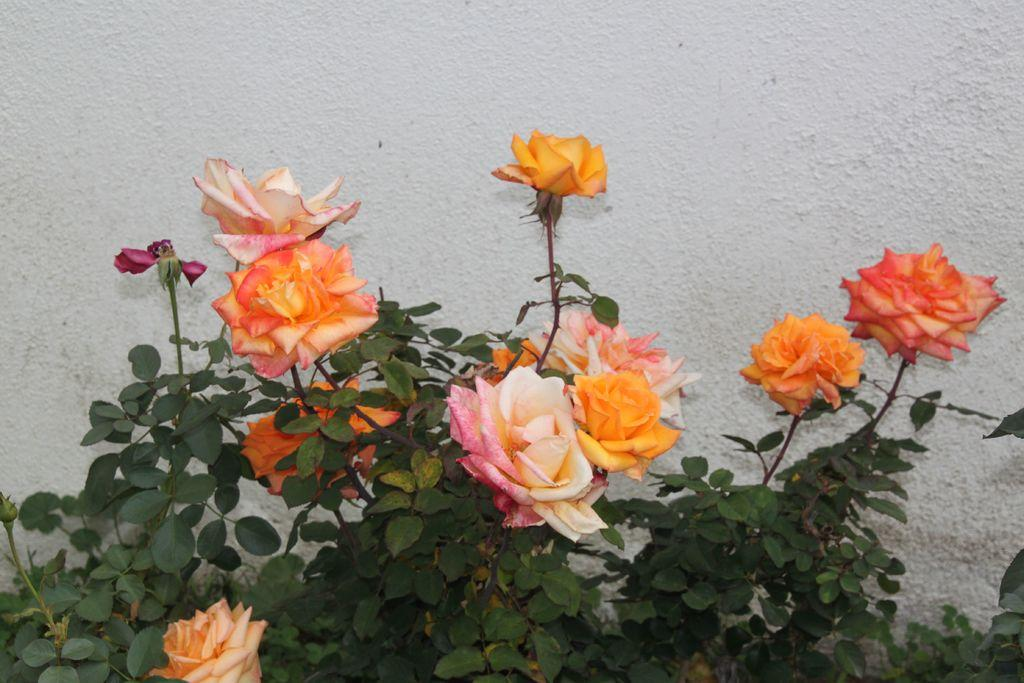What type of plants are in the front of the image? There are rose plants in the front of the image. What can be seen in the background of the image? There is a wall in the background of the image. What type of locket is hanging from the rose plants in the image? There is no locket present in the image; it only features rose plants and a wall in the background. 